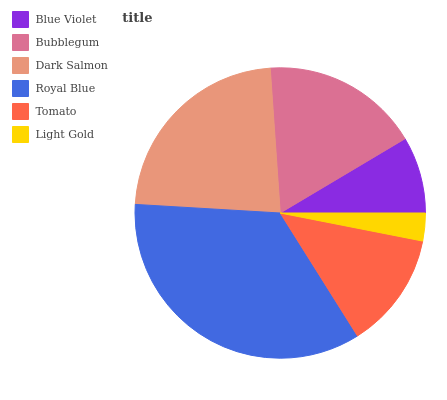Is Light Gold the minimum?
Answer yes or no. Yes. Is Royal Blue the maximum?
Answer yes or no. Yes. Is Bubblegum the minimum?
Answer yes or no. No. Is Bubblegum the maximum?
Answer yes or no. No. Is Bubblegum greater than Blue Violet?
Answer yes or no. Yes. Is Blue Violet less than Bubblegum?
Answer yes or no. Yes. Is Blue Violet greater than Bubblegum?
Answer yes or no. No. Is Bubblegum less than Blue Violet?
Answer yes or no. No. Is Bubblegum the high median?
Answer yes or no. Yes. Is Tomato the low median?
Answer yes or no. Yes. Is Dark Salmon the high median?
Answer yes or no. No. Is Dark Salmon the low median?
Answer yes or no. No. 